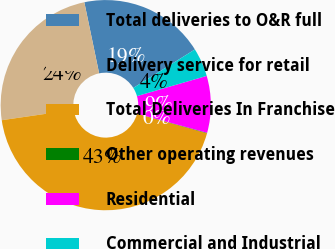Convert chart to OTSL. <chart><loc_0><loc_0><loc_500><loc_500><pie_chart><fcel>Total deliveries to O&R full<fcel>Delivery service for retail<fcel>Total Deliveries In Franchise<fcel>Other operating revenues<fcel>Residential<fcel>Commercial and Industrial<nl><fcel>19.38%<fcel>24.02%<fcel>43.4%<fcel>0.07%<fcel>8.73%<fcel>4.4%<nl></chart> 